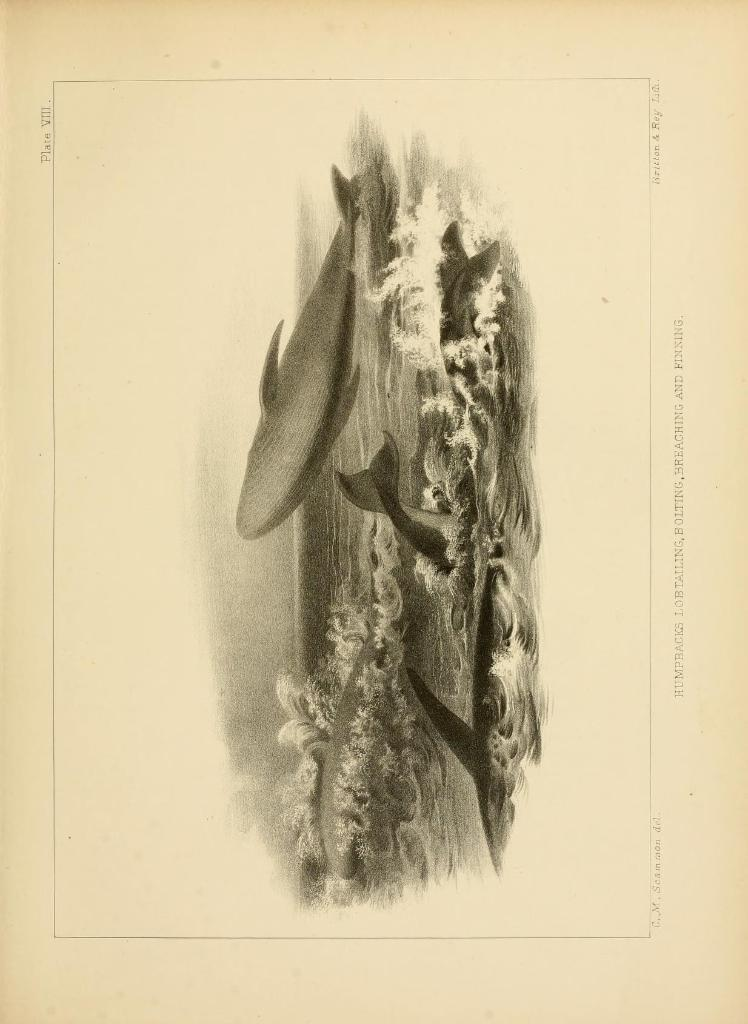What is depicted in the image? The image contains a sketch of fishes. What is the medium of the sketch? The sketch is on a paper. What is included in the sketch besides the fishes? The sketch includes water. Is there any text in the image? Yes, there is writing on the paper. What type of government is depicted in the sketch? There is no government depicted in the sketch; it is a sketch of fishes and water. How many eggs are visible in the sketch? There are no eggs present in the sketch; it features a sketch of fishes and water. 